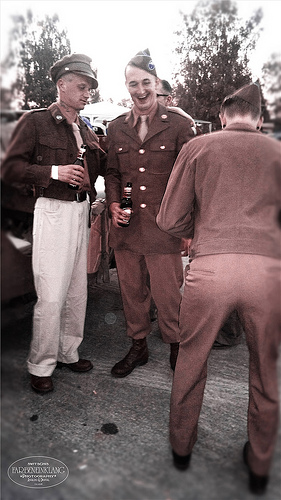<image>
Is the hat on the man? No. The hat is not positioned on the man. They may be near each other, but the hat is not supported by or resting on top of the man. 